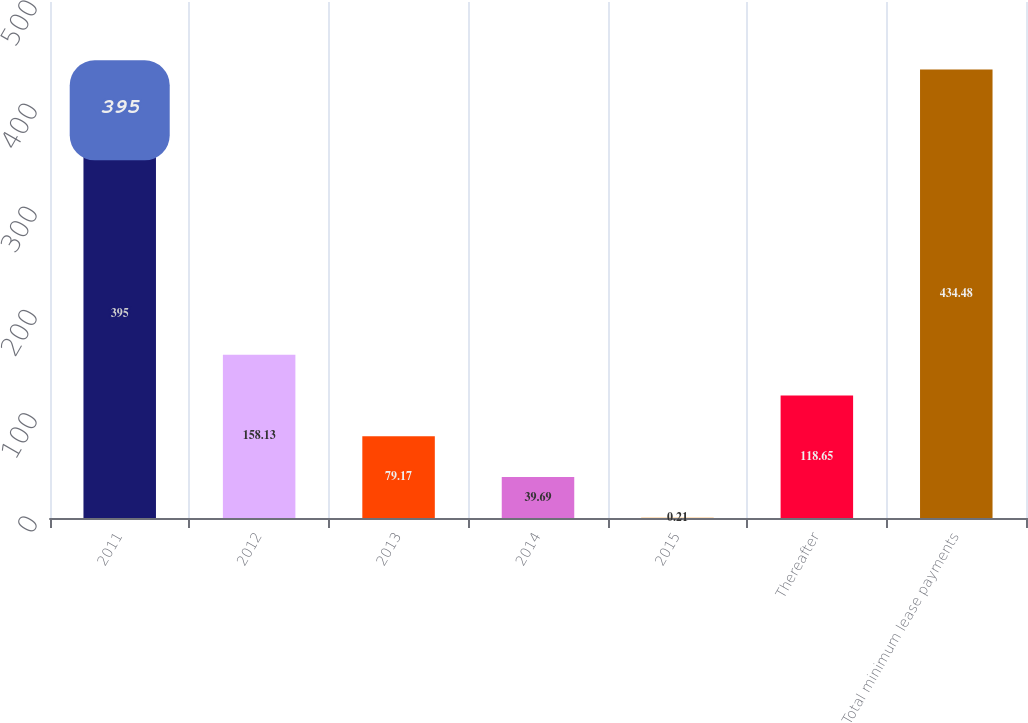<chart> <loc_0><loc_0><loc_500><loc_500><bar_chart><fcel>2011<fcel>2012<fcel>2013<fcel>2014<fcel>2015<fcel>Thereafter<fcel>Total minimum lease payments<nl><fcel>395<fcel>158.13<fcel>79.17<fcel>39.69<fcel>0.21<fcel>118.65<fcel>434.48<nl></chart> 